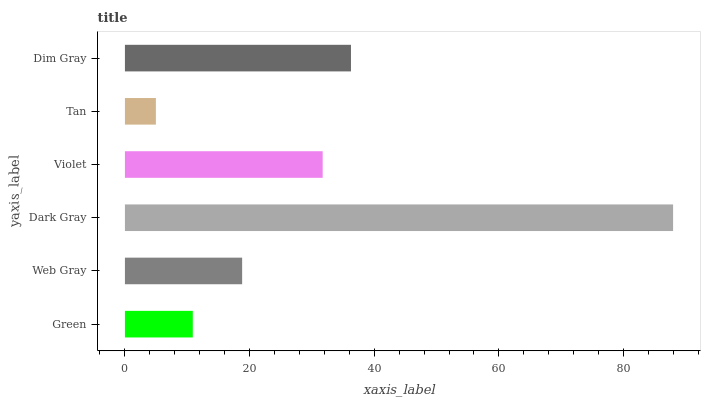Is Tan the minimum?
Answer yes or no. Yes. Is Dark Gray the maximum?
Answer yes or no. Yes. Is Web Gray the minimum?
Answer yes or no. No. Is Web Gray the maximum?
Answer yes or no. No. Is Web Gray greater than Green?
Answer yes or no. Yes. Is Green less than Web Gray?
Answer yes or no. Yes. Is Green greater than Web Gray?
Answer yes or no. No. Is Web Gray less than Green?
Answer yes or no. No. Is Violet the high median?
Answer yes or no. Yes. Is Web Gray the low median?
Answer yes or no. Yes. Is Web Gray the high median?
Answer yes or no. No. Is Violet the low median?
Answer yes or no. No. 